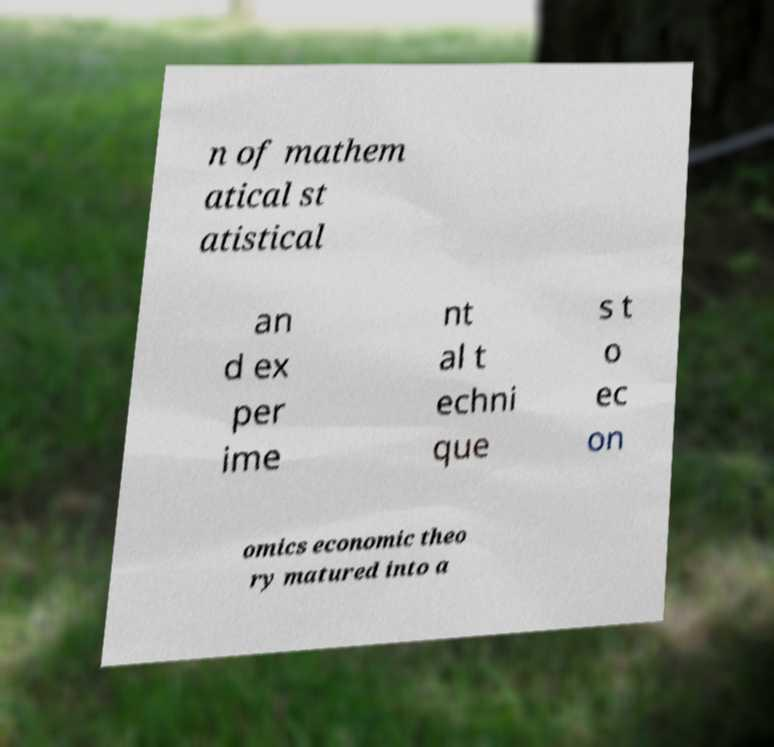I need the written content from this picture converted into text. Can you do that? n of mathem atical st atistical an d ex per ime nt al t echni que s t o ec on omics economic theo ry matured into a 